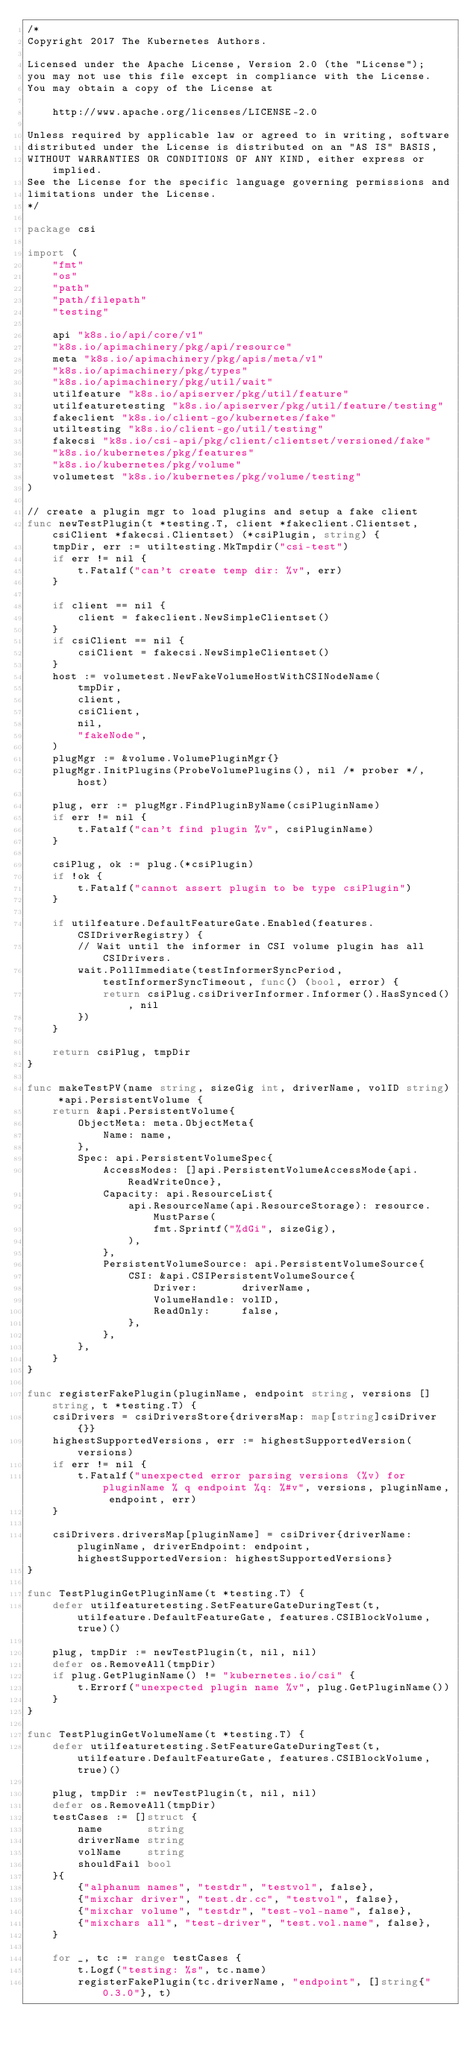Convert code to text. <code><loc_0><loc_0><loc_500><loc_500><_Go_>/*
Copyright 2017 The Kubernetes Authors.

Licensed under the Apache License, Version 2.0 (the "License");
you may not use this file except in compliance with the License.
You may obtain a copy of the License at

    http://www.apache.org/licenses/LICENSE-2.0

Unless required by applicable law or agreed to in writing, software
distributed under the License is distributed on an "AS IS" BASIS,
WITHOUT WARRANTIES OR CONDITIONS OF ANY KIND, either express or implied.
See the License for the specific language governing permissions and
limitations under the License.
*/

package csi

import (
	"fmt"
	"os"
	"path"
	"path/filepath"
	"testing"

	api "k8s.io/api/core/v1"
	"k8s.io/apimachinery/pkg/api/resource"
	meta "k8s.io/apimachinery/pkg/apis/meta/v1"
	"k8s.io/apimachinery/pkg/types"
	"k8s.io/apimachinery/pkg/util/wait"
	utilfeature "k8s.io/apiserver/pkg/util/feature"
	utilfeaturetesting "k8s.io/apiserver/pkg/util/feature/testing"
	fakeclient "k8s.io/client-go/kubernetes/fake"
	utiltesting "k8s.io/client-go/util/testing"
	fakecsi "k8s.io/csi-api/pkg/client/clientset/versioned/fake"
	"k8s.io/kubernetes/pkg/features"
	"k8s.io/kubernetes/pkg/volume"
	volumetest "k8s.io/kubernetes/pkg/volume/testing"
)

// create a plugin mgr to load plugins and setup a fake client
func newTestPlugin(t *testing.T, client *fakeclient.Clientset, csiClient *fakecsi.Clientset) (*csiPlugin, string) {
	tmpDir, err := utiltesting.MkTmpdir("csi-test")
	if err != nil {
		t.Fatalf("can't create temp dir: %v", err)
	}

	if client == nil {
		client = fakeclient.NewSimpleClientset()
	}
	if csiClient == nil {
		csiClient = fakecsi.NewSimpleClientset()
	}
	host := volumetest.NewFakeVolumeHostWithCSINodeName(
		tmpDir,
		client,
		csiClient,
		nil,
		"fakeNode",
	)
	plugMgr := &volume.VolumePluginMgr{}
	plugMgr.InitPlugins(ProbeVolumePlugins(), nil /* prober */, host)

	plug, err := plugMgr.FindPluginByName(csiPluginName)
	if err != nil {
		t.Fatalf("can't find plugin %v", csiPluginName)
	}

	csiPlug, ok := plug.(*csiPlugin)
	if !ok {
		t.Fatalf("cannot assert plugin to be type csiPlugin")
	}

	if utilfeature.DefaultFeatureGate.Enabled(features.CSIDriverRegistry) {
		// Wait until the informer in CSI volume plugin has all CSIDrivers.
		wait.PollImmediate(testInformerSyncPeriod, testInformerSyncTimeout, func() (bool, error) {
			return csiPlug.csiDriverInformer.Informer().HasSynced(), nil
		})
	}

	return csiPlug, tmpDir
}

func makeTestPV(name string, sizeGig int, driverName, volID string) *api.PersistentVolume {
	return &api.PersistentVolume{
		ObjectMeta: meta.ObjectMeta{
			Name: name,
		},
		Spec: api.PersistentVolumeSpec{
			AccessModes: []api.PersistentVolumeAccessMode{api.ReadWriteOnce},
			Capacity: api.ResourceList{
				api.ResourceName(api.ResourceStorage): resource.MustParse(
					fmt.Sprintf("%dGi", sizeGig),
				),
			},
			PersistentVolumeSource: api.PersistentVolumeSource{
				CSI: &api.CSIPersistentVolumeSource{
					Driver:       driverName,
					VolumeHandle: volID,
					ReadOnly:     false,
				},
			},
		},
	}
}

func registerFakePlugin(pluginName, endpoint string, versions []string, t *testing.T) {
	csiDrivers = csiDriversStore{driversMap: map[string]csiDriver{}}
	highestSupportedVersions, err := highestSupportedVersion(versions)
	if err != nil {
		t.Fatalf("unexpected error parsing versions (%v) for pluginName % q endpoint %q: %#v", versions, pluginName, endpoint, err)
	}

	csiDrivers.driversMap[pluginName] = csiDriver{driverName: pluginName, driverEndpoint: endpoint, highestSupportedVersion: highestSupportedVersions}
}

func TestPluginGetPluginName(t *testing.T) {
	defer utilfeaturetesting.SetFeatureGateDuringTest(t, utilfeature.DefaultFeatureGate, features.CSIBlockVolume, true)()

	plug, tmpDir := newTestPlugin(t, nil, nil)
	defer os.RemoveAll(tmpDir)
	if plug.GetPluginName() != "kubernetes.io/csi" {
		t.Errorf("unexpected plugin name %v", plug.GetPluginName())
	}
}

func TestPluginGetVolumeName(t *testing.T) {
	defer utilfeaturetesting.SetFeatureGateDuringTest(t, utilfeature.DefaultFeatureGate, features.CSIBlockVolume, true)()

	plug, tmpDir := newTestPlugin(t, nil, nil)
	defer os.RemoveAll(tmpDir)
	testCases := []struct {
		name       string
		driverName string
		volName    string
		shouldFail bool
	}{
		{"alphanum names", "testdr", "testvol", false},
		{"mixchar driver", "test.dr.cc", "testvol", false},
		{"mixchar volume", "testdr", "test-vol-name", false},
		{"mixchars all", "test-driver", "test.vol.name", false},
	}

	for _, tc := range testCases {
		t.Logf("testing: %s", tc.name)
		registerFakePlugin(tc.driverName, "endpoint", []string{"0.3.0"}, t)</code> 